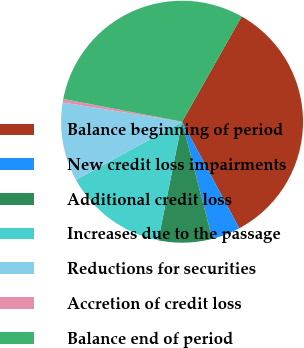<chart> <loc_0><loc_0><loc_500><loc_500><pie_chart><fcel>Balance beginning of period<fcel>New credit loss impairments<fcel>Additional credit loss<fcel>Increases due to the passage<fcel>Reductions for securities<fcel>Accretion of credit loss<fcel>Balance end of period<nl><fcel>33.96%<fcel>3.82%<fcel>7.17%<fcel>13.87%<fcel>10.52%<fcel>0.47%<fcel>30.18%<nl></chart> 